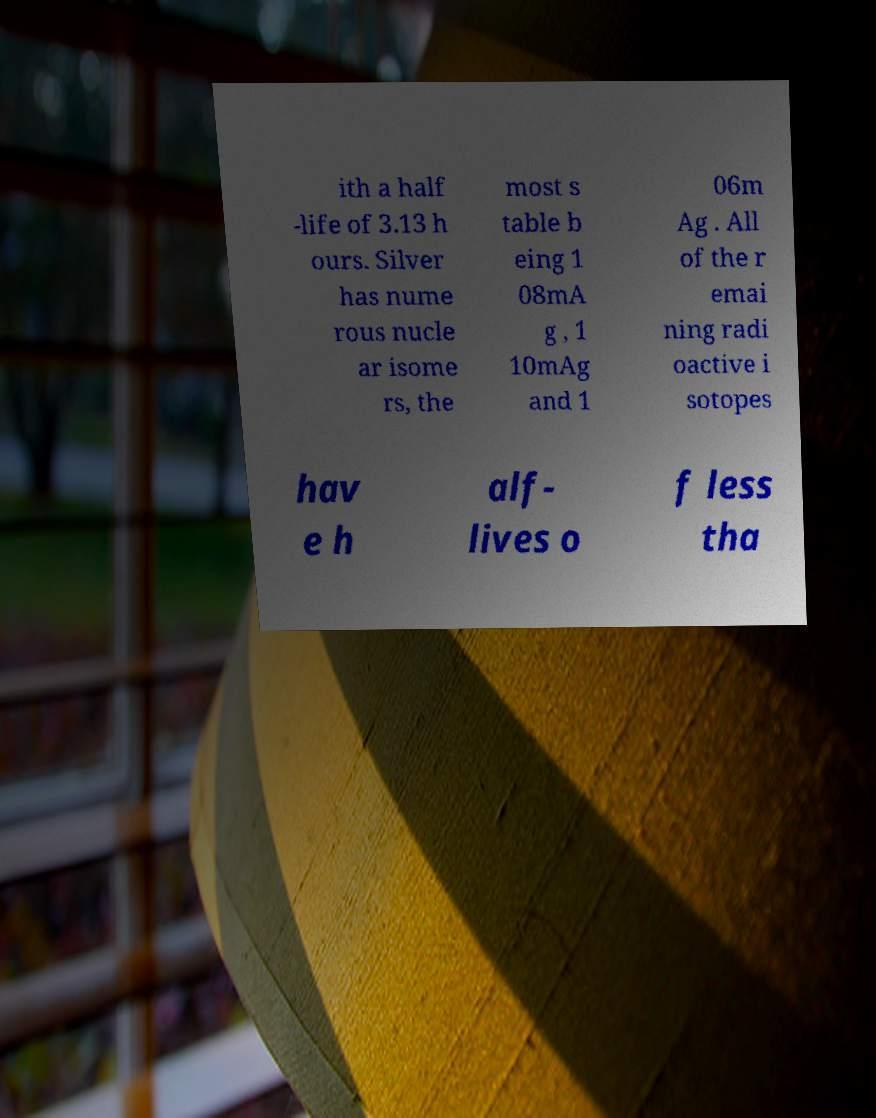Can you accurately transcribe the text from the provided image for me? ith a half -life of 3.13 h ours. Silver has nume rous nucle ar isome rs, the most s table b eing 1 08mA g , 1 10mAg and 1 06m Ag . All of the r emai ning radi oactive i sotopes hav e h alf- lives o f less tha 